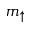Convert formula to latex. <formula><loc_0><loc_0><loc_500><loc_500>m _ { \uparrow }</formula> 